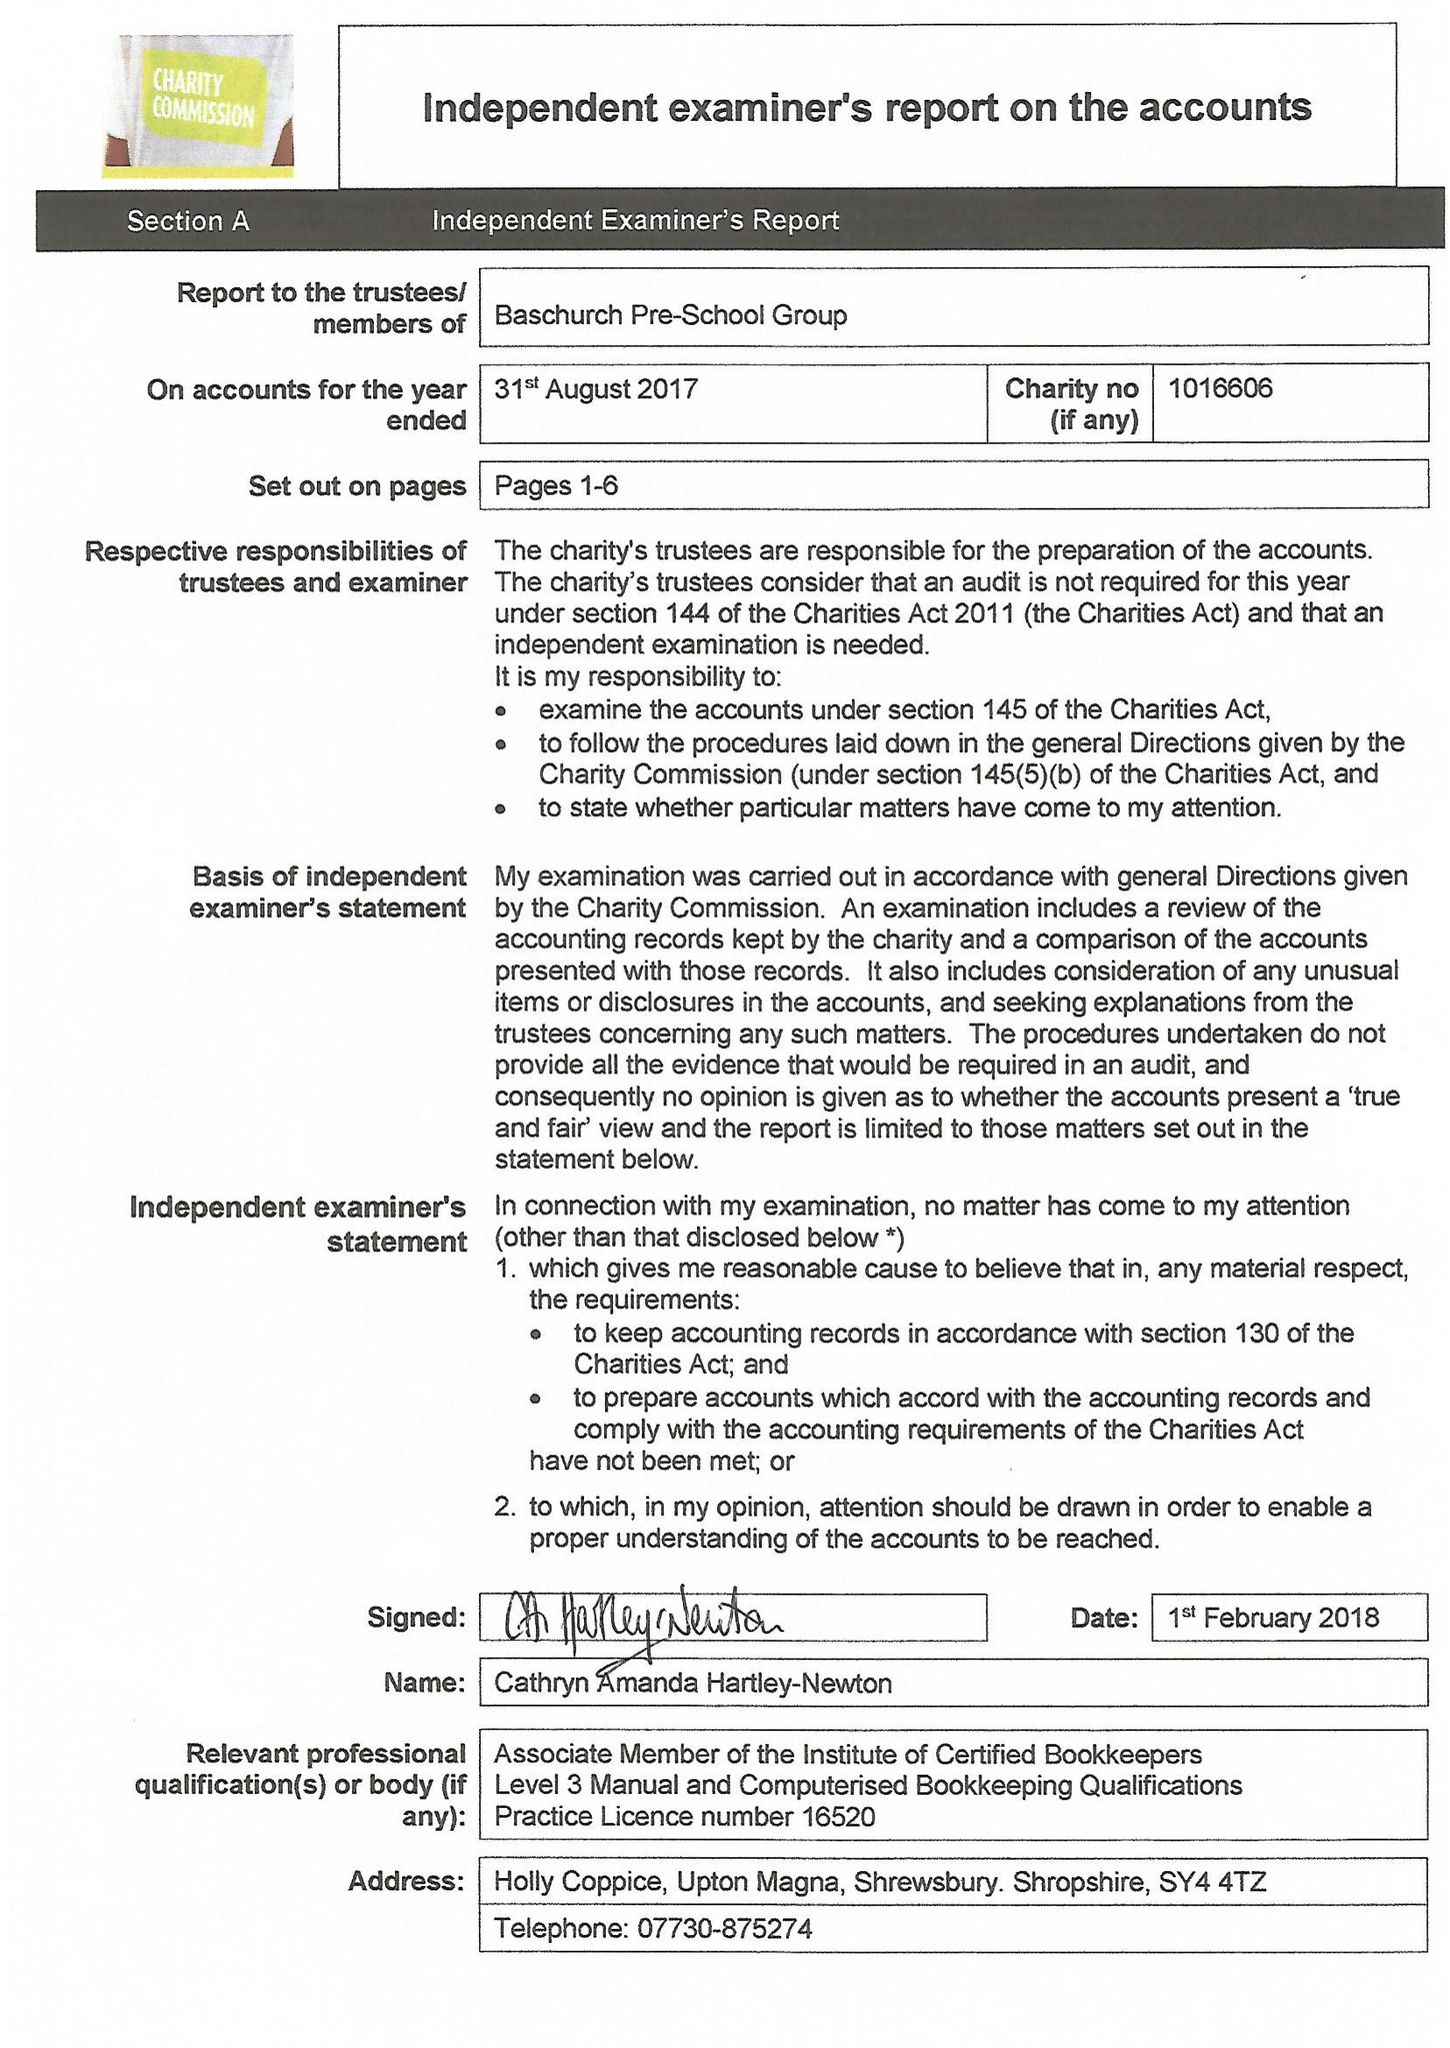What is the value for the report_date?
Answer the question using a single word or phrase. 2017-08-31 